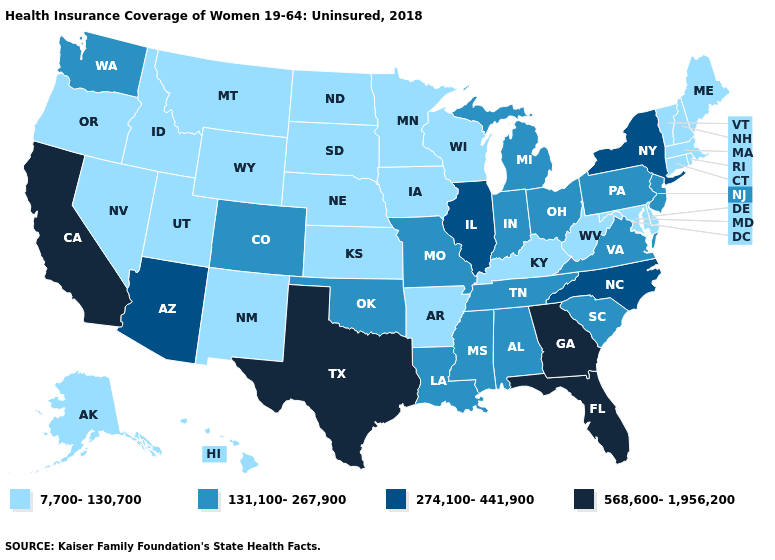Name the states that have a value in the range 131,100-267,900?
Short answer required. Alabama, Colorado, Indiana, Louisiana, Michigan, Mississippi, Missouri, New Jersey, Ohio, Oklahoma, Pennsylvania, South Carolina, Tennessee, Virginia, Washington. What is the highest value in the South ?
Keep it brief. 568,600-1,956,200. Which states hav the highest value in the South?
Answer briefly. Florida, Georgia, Texas. What is the value of Montana?
Keep it brief. 7,700-130,700. Name the states that have a value in the range 7,700-130,700?
Write a very short answer. Alaska, Arkansas, Connecticut, Delaware, Hawaii, Idaho, Iowa, Kansas, Kentucky, Maine, Maryland, Massachusetts, Minnesota, Montana, Nebraska, Nevada, New Hampshire, New Mexico, North Dakota, Oregon, Rhode Island, South Dakota, Utah, Vermont, West Virginia, Wisconsin, Wyoming. Does Arizona have the highest value in the West?
Keep it brief. No. What is the value of Virginia?
Quick response, please. 131,100-267,900. Name the states that have a value in the range 131,100-267,900?
Write a very short answer. Alabama, Colorado, Indiana, Louisiana, Michigan, Mississippi, Missouri, New Jersey, Ohio, Oklahoma, Pennsylvania, South Carolina, Tennessee, Virginia, Washington. Does Illinois have the highest value in the MidWest?
Keep it brief. Yes. What is the lowest value in the USA?
Answer briefly. 7,700-130,700. What is the value of Iowa?
Be succinct. 7,700-130,700. What is the highest value in the MidWest ?
Keep it brief. 274,100-441,900. Is the legend a continuous bar?
Answer briefly. No. Which states hav the highest value in the South?
Write a very short answer. Florida, Georgia, Texas. How many symbols are there in the legend?
Short answer required. 4. 